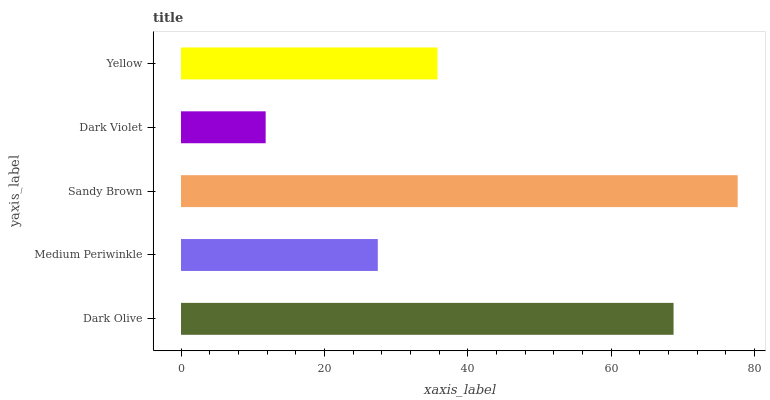Is Dark Violet the minimum?
Answer yes or no. Yes. Is Sandy Brown the maximum?
Answer yes or no. Yes. Is Medium Periwinkle the minimum?
Answer yes or no. No. Is Medium Periwinkle the maximum?
Answer yes or no. No. Is Dark Olive greater than Medium Periwinkle?
Answer yes or no. Yes. Is Medium Periwinkle less than Dark Olive?
Answer yes or no. Yes. Is Medium Periwinkle greater than Dark Olive?
Answer yes or no. No. Is Dark Olive less than Medium Periwinkle?
Answer yes or no. No. Is Yellow the high median?
Answer yes or no. Yes. Is Yellow the low median?
Answer yes or no. Yes. Is Sandy Brown the high median?
Answer yes or no. No. Is Medium Periwinkle the low median?
Answer yes or no. No. 